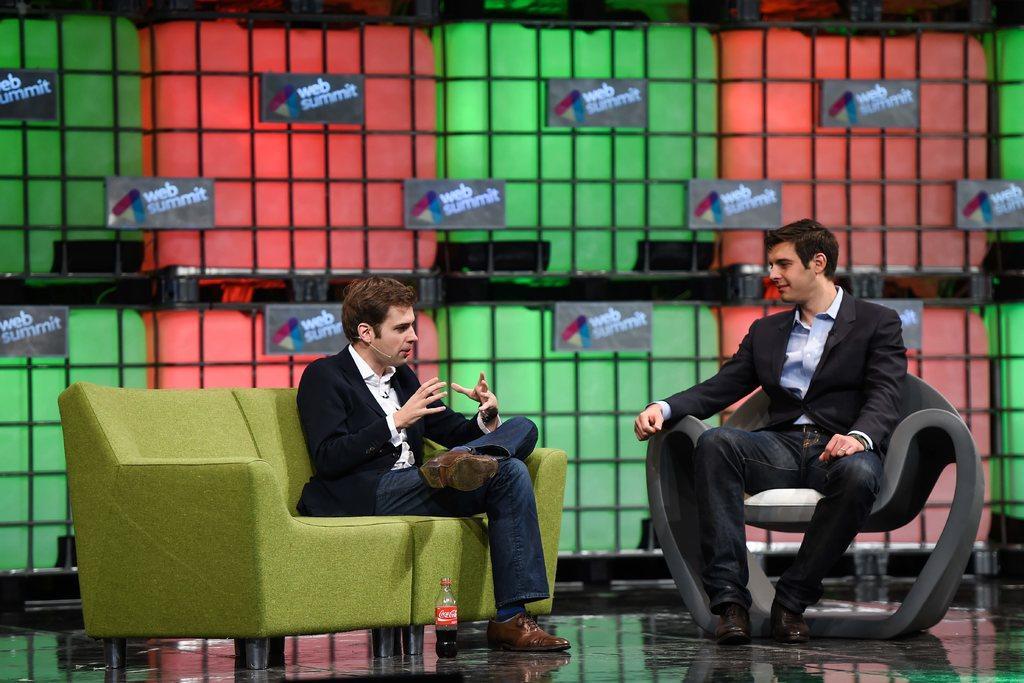In one or two sentences, can you explain what this image depicts? In this image I can see two persons sitting. The person at right is wearing black blazer and blue color shirt and the person at left is wearing black blazer and white color shirt and I can see the green and red color background. I can see few boards attached to the grill. 